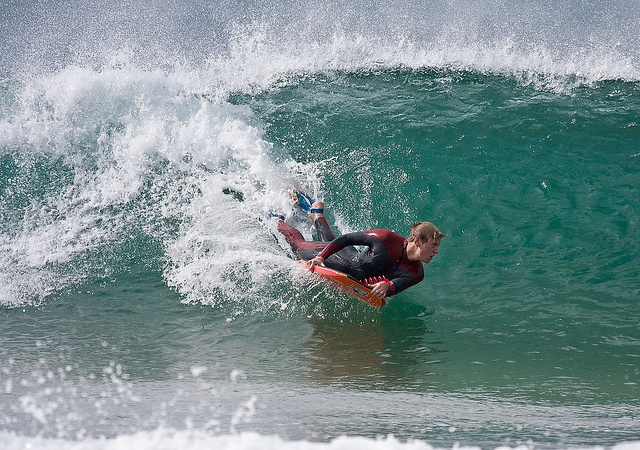Describe the objects in this image and their specific colors. I can see people in gray, black, brown, and maroon tones and surfboard in gray, maroon, and black tones in this image. 